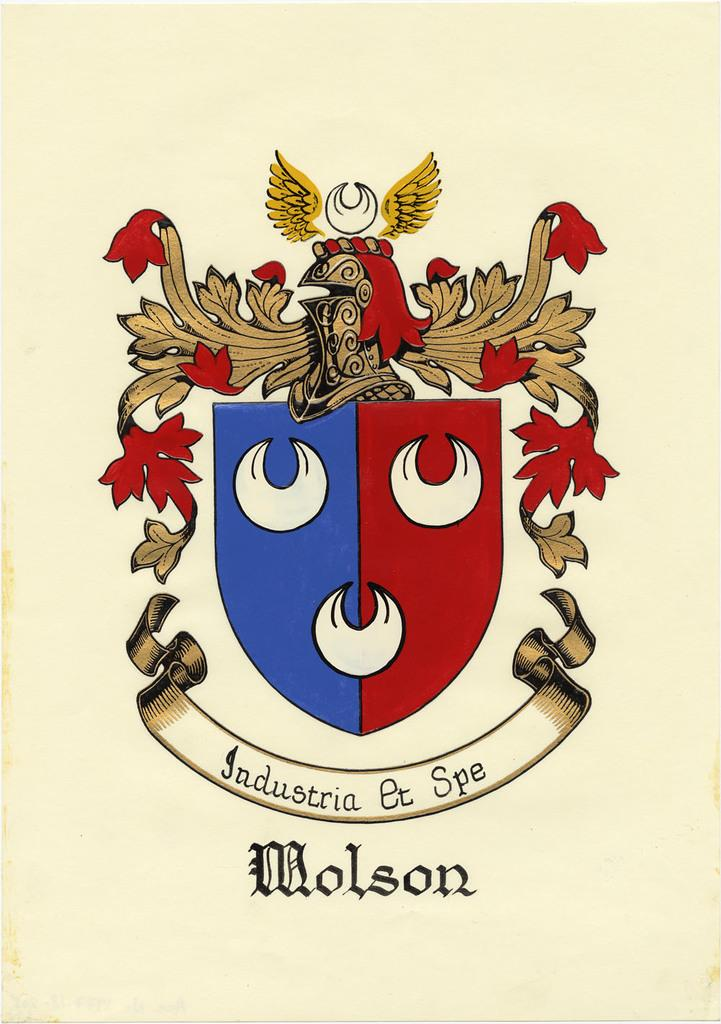<image>
Provide a brief description of the given image. Coat of arms for a nation of a country named Molson. 